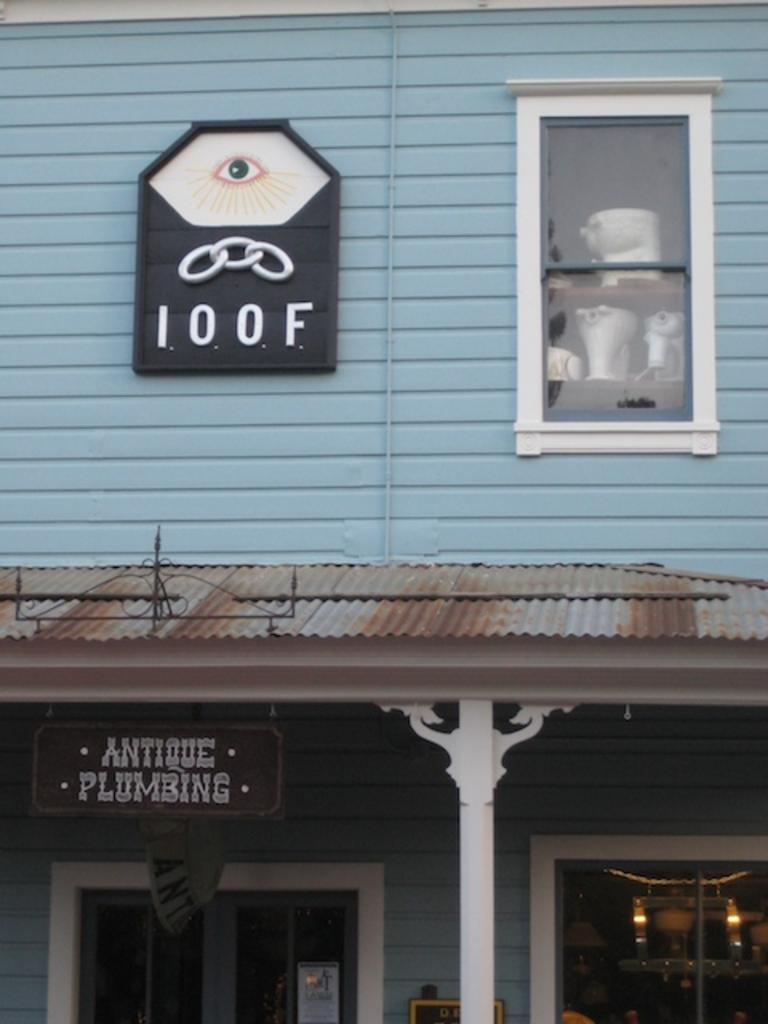<image>
Relay a brief, clear account of the picture shown. A blue building has a sign that reads Antique Plumbing. 